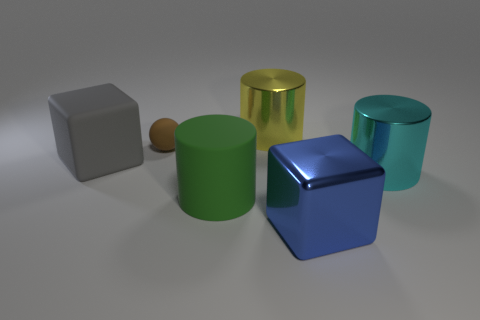Add 2 tiny cyan cylinders. How many objects exist? 8 Subtract all balls. How many objects are left? 5 Add 5 blue metal blocks. How many blue metal blocks exist? 6 Subtract 0 gray balls. How many objects are left? 6 Subtract all yellow shiny cylinders. Subtract all brown balls. How many objects are left? 4 Add 3 large yellow cylinders. How many large yellow cylinders are left? 4 